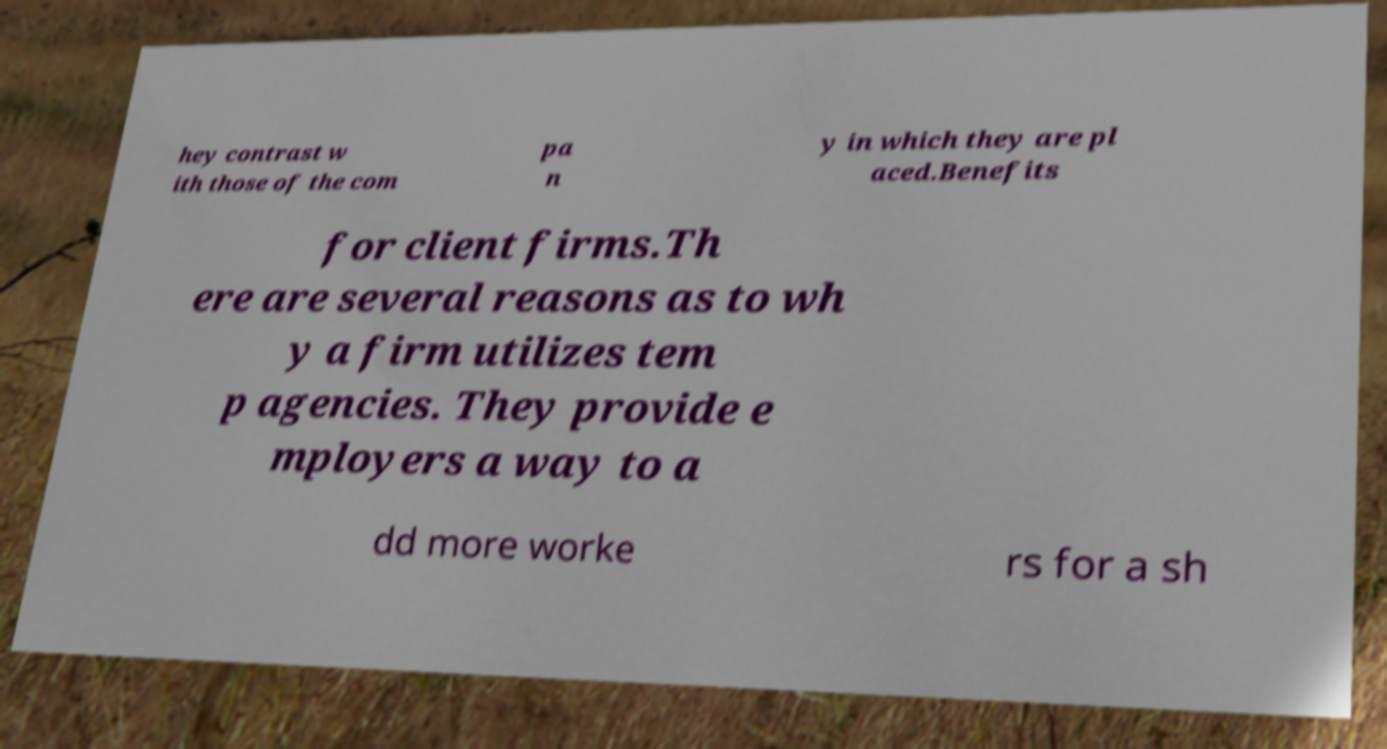Can you accurately transcribe the text from the provided image for me? hey contrast w ith those of the com pa n y in which they are pl aced.Benefits for client firms.Th ere are several reasons as to wh y a firm utilizes tem p agencies. They provide e mployers a way to a dd more worke rs for a sh 